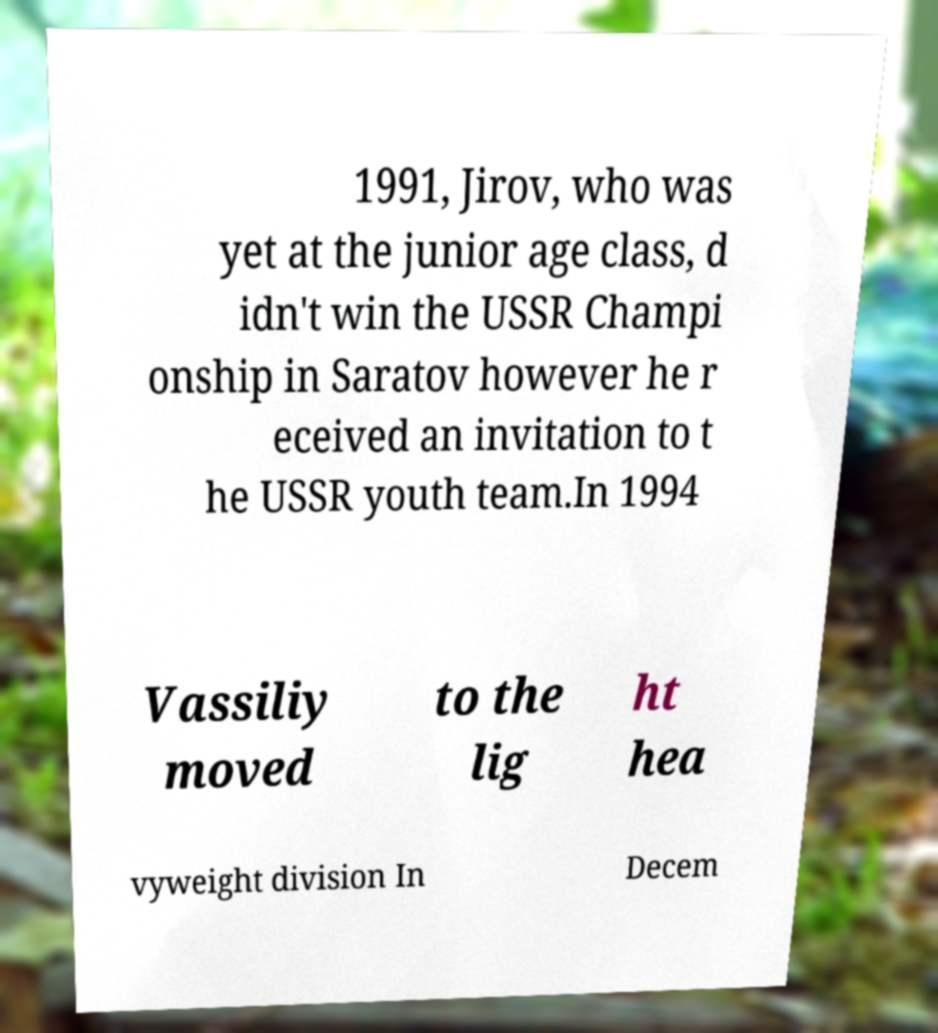Please identify and transcribe the text found in this image. 1991, Jirov, who was yet at the junior age class, d idn't win the USSR Champi onship in Saratov however he r eceived an invitation to t he USSR youth team.In 1994 Vassiliy moved to the lig ht hea vyweight division In Decem 